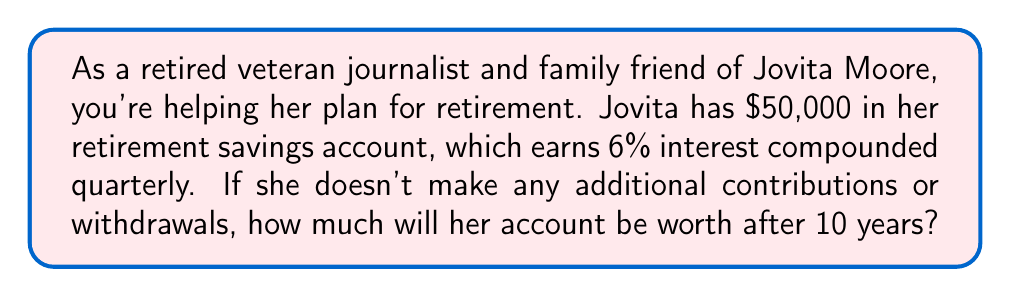What is the answer to this math problem? To solve this problem, we'll use the compound interest formula:

$$A = P(1 + \frac{r}{n})^{nt}$$

Where:
$A$ = final amount
$P$ = principal (initial investment)
$r$ = annual interest rate (as a decimal)
$n$ = number of times interest is compounded per year
$t$ = number of years

Given:
$P = \$50,000$
$r = 0.06$ (6% expressed as a decimal)
$n = 4$ (compounded quarterly, so 4 times per year)
$t = 10$ years

Let's substitute these values into the formula:

$$A = 50,000(1 + \frac{0.06}{4})^{4(10)}$$

$$A = 50,000(1 + 0.015)^{40}$$

$$A = 50,000(1.015)^{40}$$

Using a calculator to evaluate this expression:

$$A = 50,000 * 1.816771$$

$$A = 90,838.55$$

Therefore, after 10 years, Jovita's retirement savings account will be worth $90,838.55.
Answer: $90,838.55 